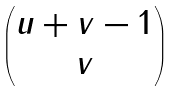Convert formula to latex. <formula><loc_0><loc_0><loc_500><loc_500>\begin{pmatrix} u + v - 1 \\ v \end{pmatrix}</formula> 